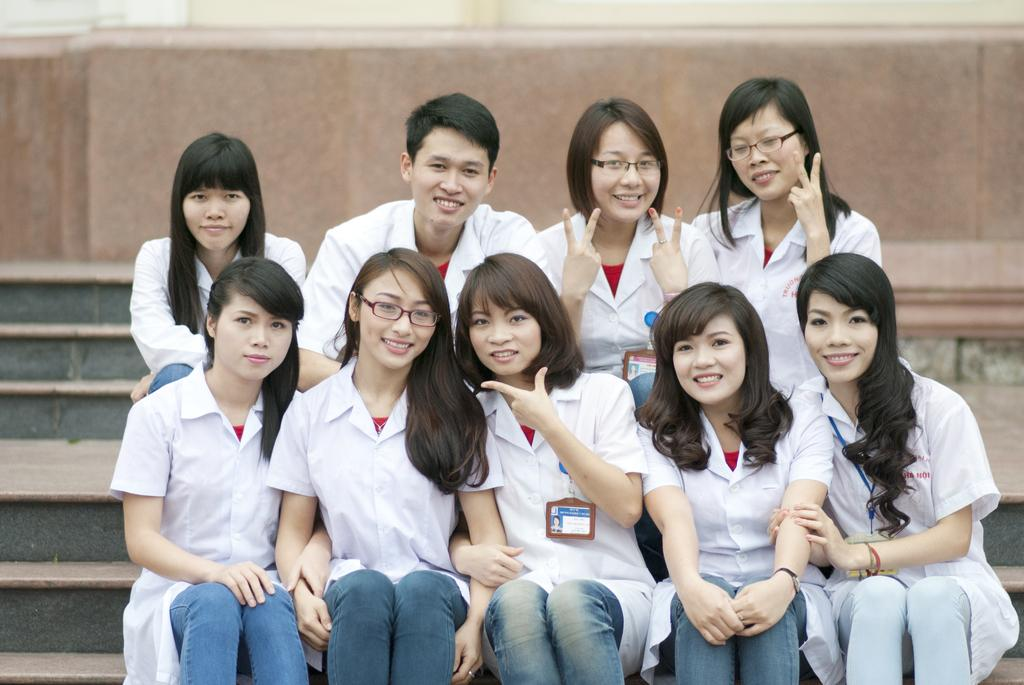What are the people in the image doing? The people in the image are sitting on the stairs. What is the facial expression of the people in the image? The people are smiling. What can be seen in the background of the image? There is a wall in the background of the image. What type of toy is being played with on the stairs in the image? There is no toy present in the image; the people are simply sitting on the stairs and smiling. 